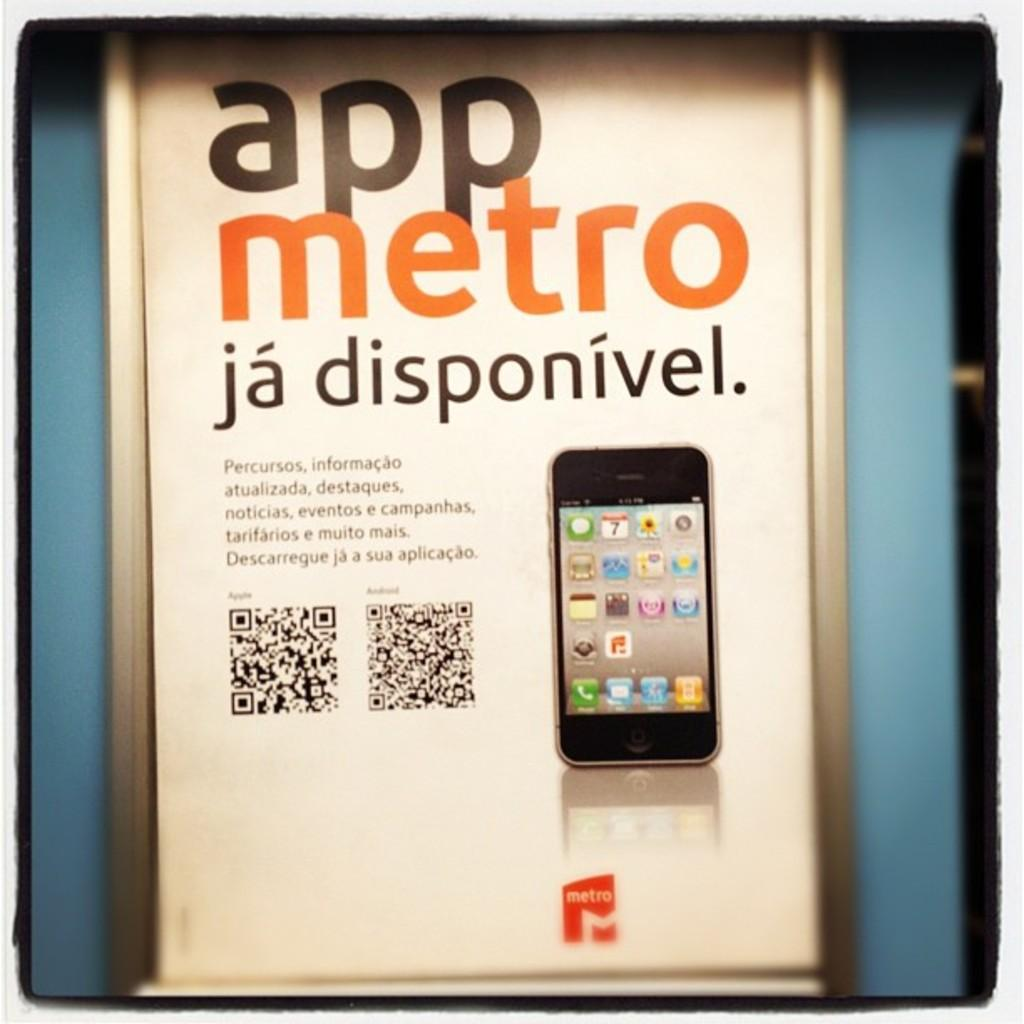Provide a one-sentence caption for the provided image. the app metro that has a phone on it. 